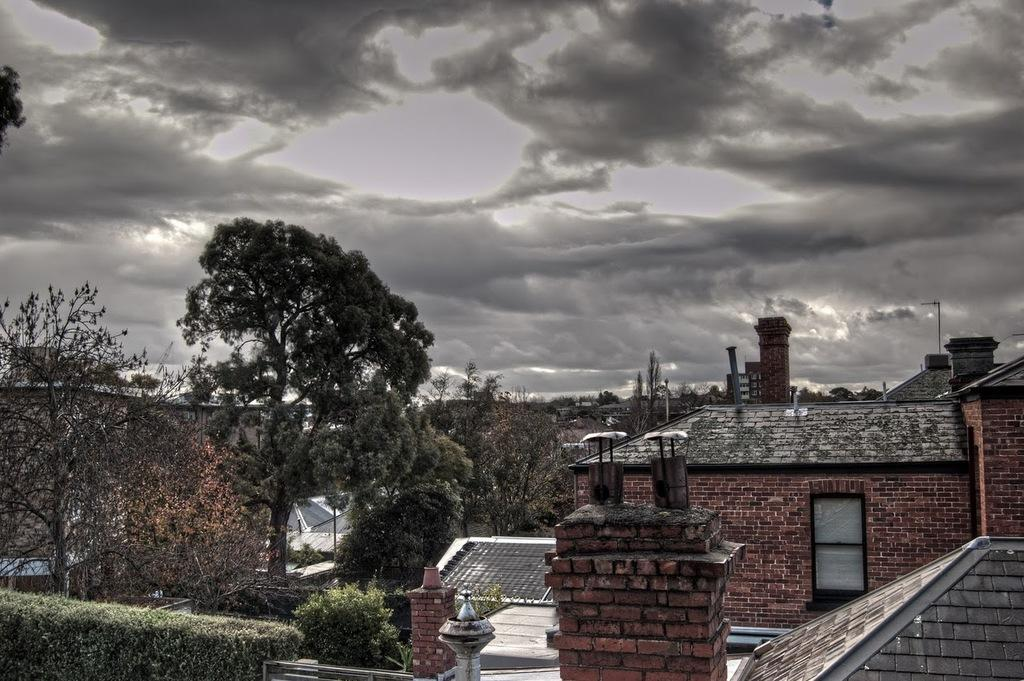What type of structures can be seen in the image? There are buildings in the image. What type of natural elements can be seen in the image? There are trees and plants in the image. What type of man-made objects can be seen in the image? There are poles in the image. Can you describe the entrance in the image? There is a door in the image. What is visible in the background of the image? The sky with clouds is visible in the background of the image. What type of news can be seen on the bridge in the image? There is no bridge present in the image, and therefore no news can be seen on it. What type of plants are growing on the news in the image? There is no news present in the image, and therefore no plants can be growing on it. 